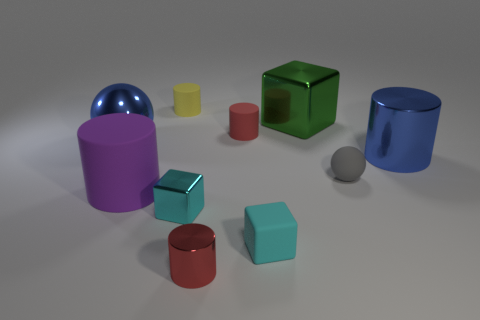Subtract all blue cylinders. How many cylinders are left? 4 Subtract all big blue cylinders. How many cylinders are left? 4 Subtract all red cylinders. Subtract all yellow spheres. How many cylinders are left? 3 Subtract all balls. How many objects are left? 8 Add 2 blue metallic things. How many blue metallic things exist? 4 Subtract 1 yellow cylinders. How many objects are left? 9 Subtract all large blue matte balls. Subtract all blue shiny things. How many objects are left? 8 Add 6 matte balls. How many matte balls are left? 7 